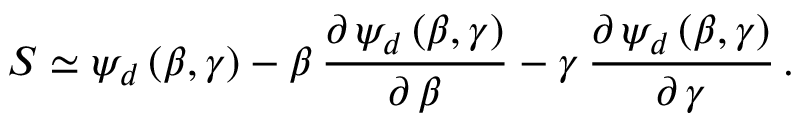<formula> <loc_0><loc_0><loc_500><loc_500>S \simeq \psi _ { d } \, ( \beta , \gamma ) - \beta \, \frac { \partial \, \psi _ { d } \, ( \beta , \gamma ) } { \partial \, \beta } - \gamma \, \frac { \partial \, \psi _ { d } \, ( \beta , \gamma ) } { \partial \, \gamma } \, .</formula> 